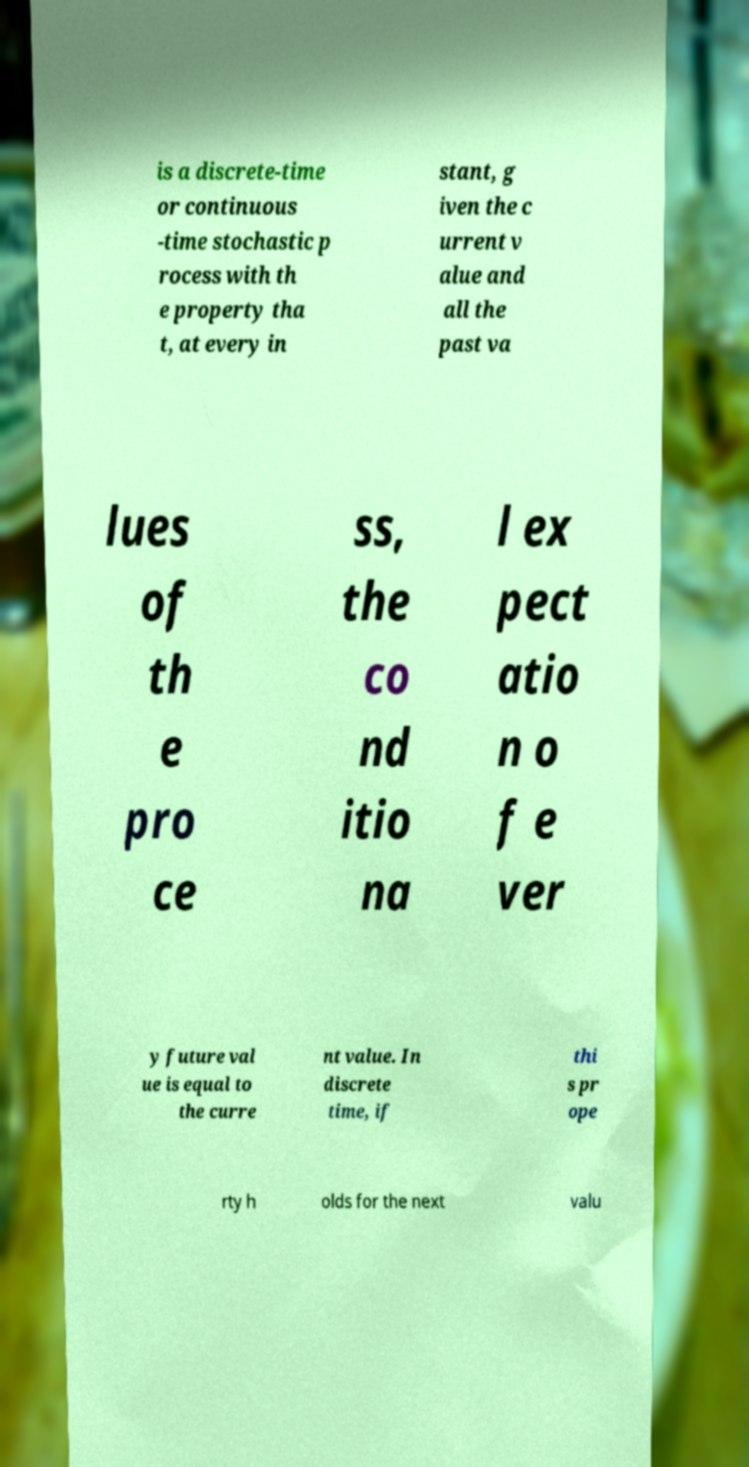Please read and relay the text visible in this image. What does it say? is a discrete-time or continuous -time stochastic p rocess with th e property tha t, at every in stant, g iven the c urrent v alue and all the past va lues of th e pro ce ss, the co nd itio na l ex pect atio n o f e ver y future val ue is equal to the curre nt value. In discrete time, if thi s pr ope rty h olds for the next valu 